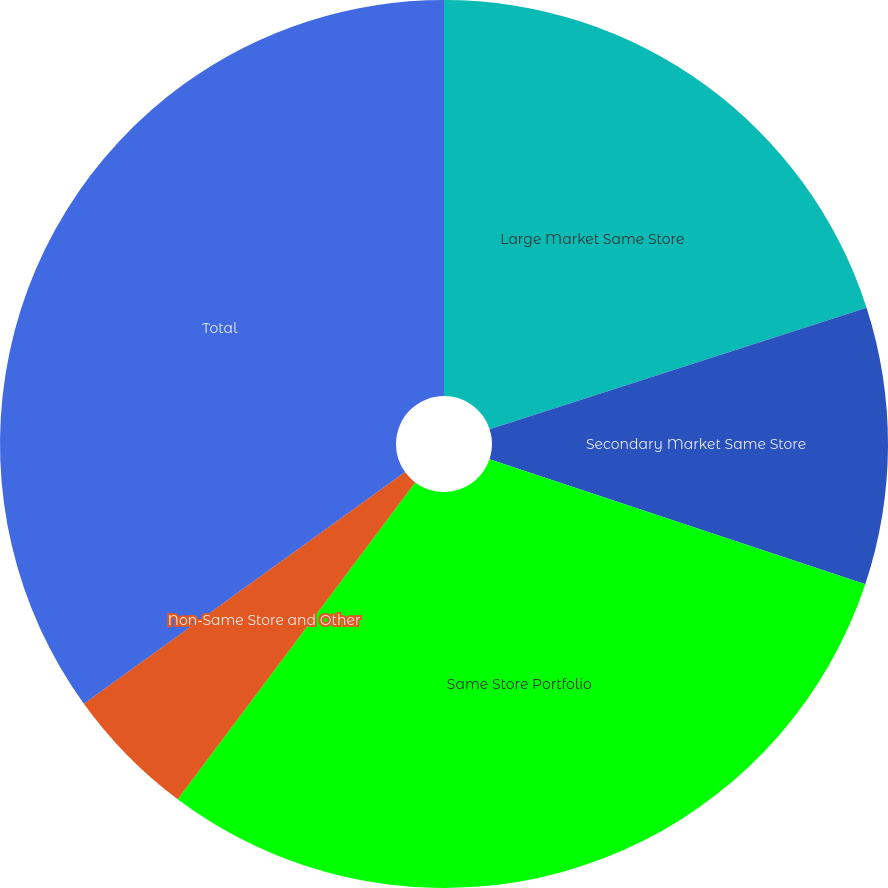Convert chart to OTSL. <chart><loc_0><loc_0><loc_500><loc_500><pie_chart><fcel>Large Market Same Store<fcel>Secondary Market Same Store<fcel>Same Store Portfolio<fcel>Non-Same Store and Other<fcel>Total<nl><fcel>20.03%<fcel>10.08%<fcel>30.12%<fcel>4.82%<fcel>34.94%<nl></chart> 